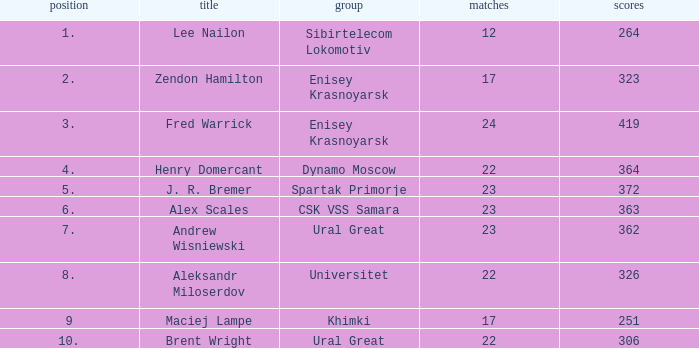What was the game with a rank higher than 2 and a name of zendon hamilton? None. 